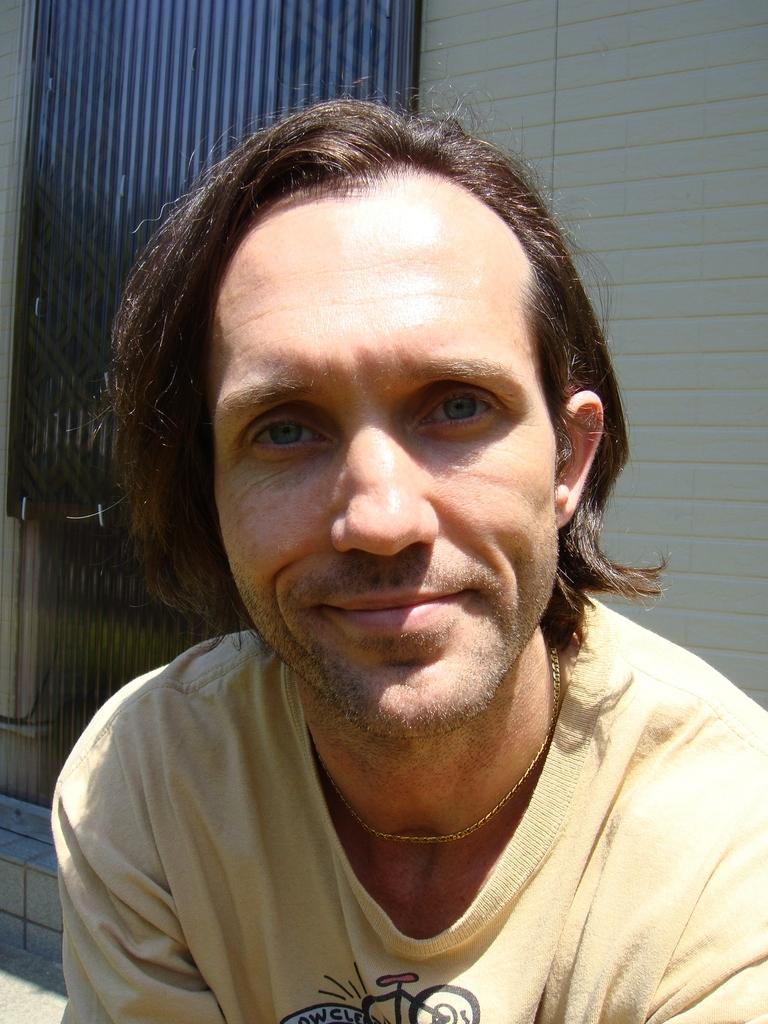Who or what is present in the image? There is a person in the image. What is the person wearing? The person is wearing a shirt. What can be seen in the background of the image? There is a wall in the background of the image. What is the wall made of? The wall has a metal gate. Is the person trying to increase the amount of wood in the image? There is no wood present in the image, so it is not possible to determine if the person is trying to increase its amount. 